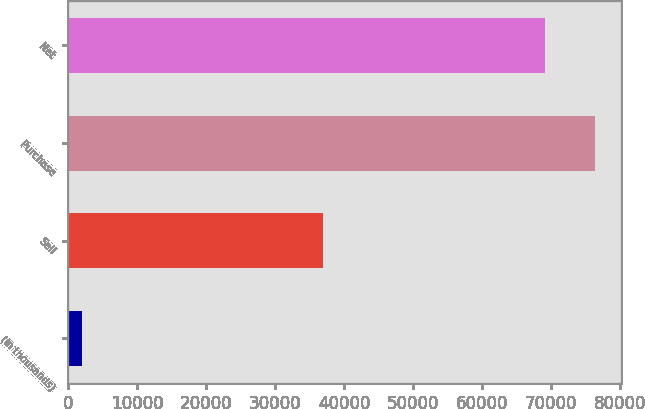Convert chart to OTSL. <chart><loc_0><loc_0><loc_500><loc_500><bar_chart><fcel>(In thousands)<fcel>Sell<fcel>Purchase<fcel>Net<nl><fcel>2009<fcel>36938<fcel>76294.5<fcel>69104<nl></chart> 